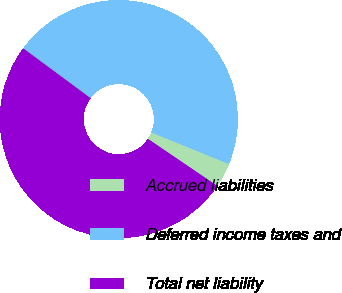Convert chart to OTSL. <chart><loc_0><loc_0><loc_500><loc_500><pie_chart><fcel>Accrued liabilities<fcel>Deferred income taxes and<fcel>Total net liability<nl><fcel>3.33%<fcel>46.03%<fcel>50.64%<nl></chart> 